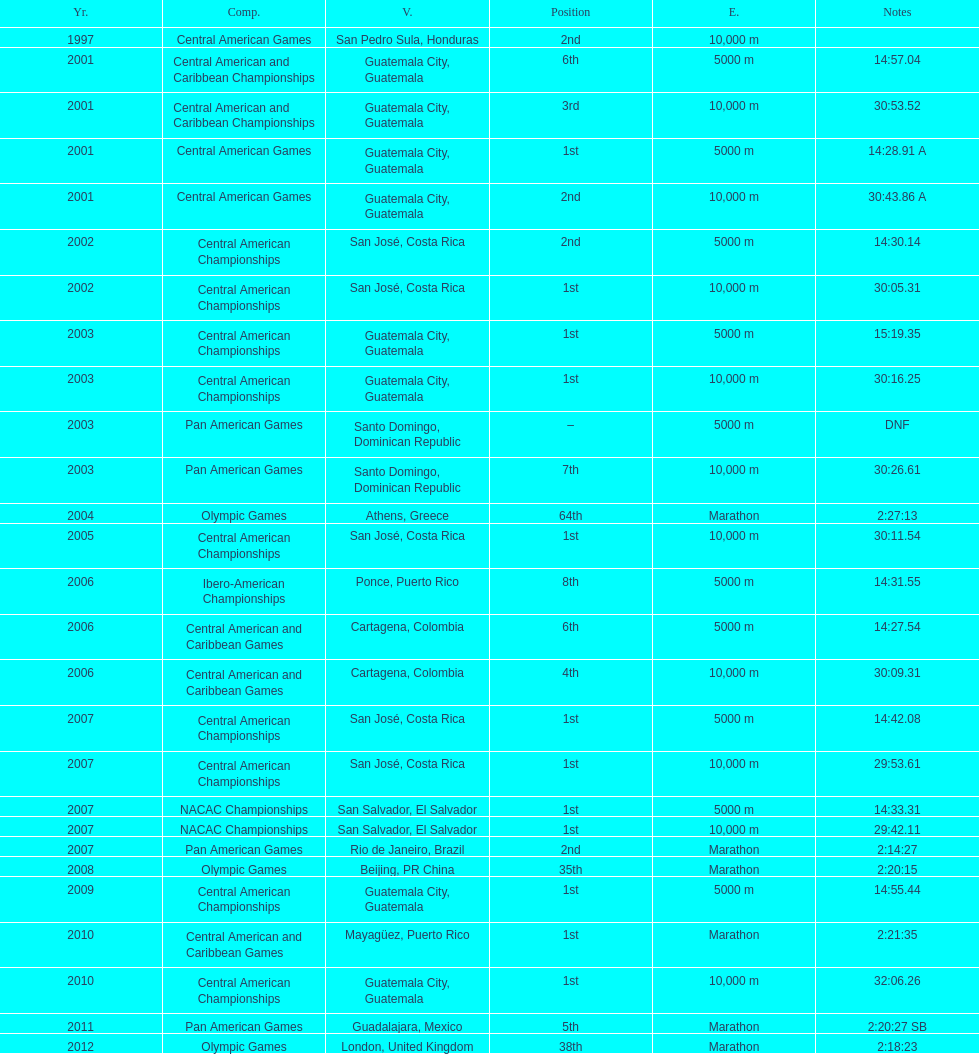Which of each game in 2007 was in the 2nd position? Pan American Games. 